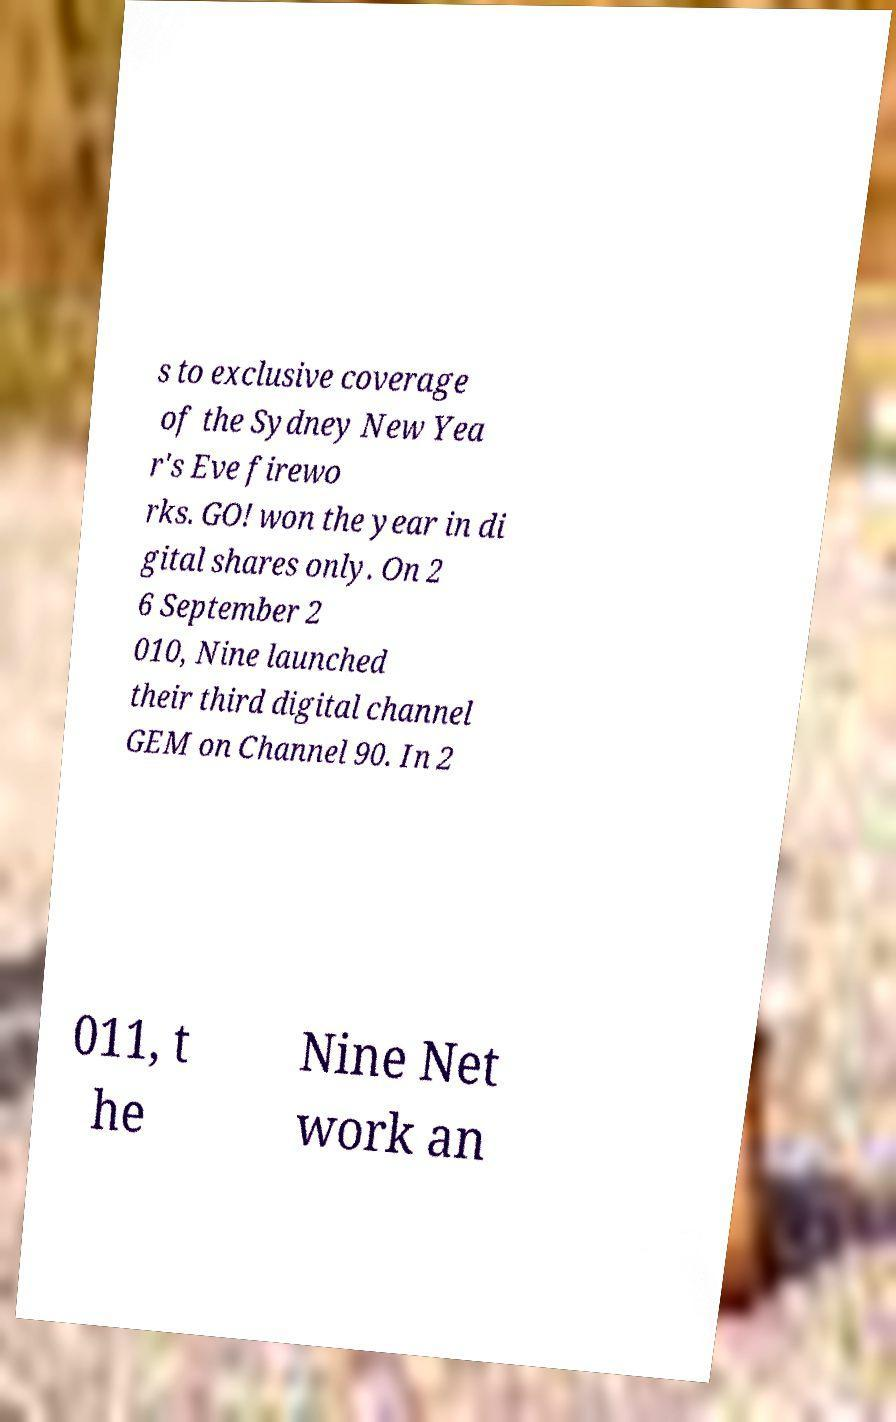Can you read and provide the text displayed in the image?This photo seems to have some interesting text. Can you extract and type it out for me? s to exclusive coverage of the Sydney New Yea r's Eve firewo rks. GO! won the year in di gital shares only. On 2 6 September 2 010, Nine launched their third digital channel GEM on Channel 90. In 2 011, t he Nine Net work an 